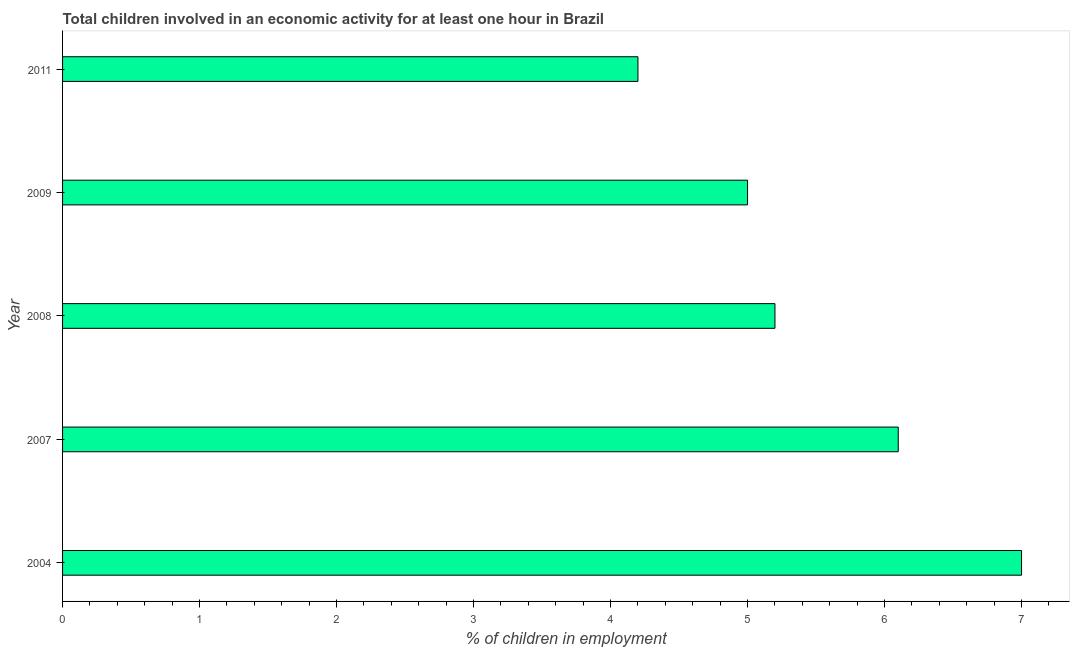Does the graph contain any zero values?
Offer a very short reply. No. Does the graph contain grids?
Provide a short and direct response. No. What is the title of the graph?
Make the answer very short. Total children involved in an economic activity for at least one hour in Brazil. What is the label or title of the X-axis?
Your answer should be compact. % of children in employment. What is the label or title of the Y-axis?
Your answer should be very brief. Year. Across all years, what is the maximum percentage of children in employment?
Make the answer very short. 7. In which year was the percentage of children in employment maximum?
Keep it short and to the point. 2004. What is the difference between the percentage of children in employment in 2009 and 2011?
Ensure brevity in your answer.  0.8. In how many years, is the percentage of children in employment greater than 0.4 %?
Provide a succinct answer. 5. What is the ratio of the percentage of children in employment in 2004 to that in 2009?
Your answer should be very brief. 1.4. Is the percentage of children in employment in 2007 less than that in 2011?
Your answer should be very brief. No. Is the difference between the percentage of children in employment in 2007 and 2008 greater than the difference between any two years?
Keep it short and to the point. No. What is the difference between the highest and the lowest percentage of children in employment?
Give a very brief answer. 2.8. How many bars are there?
Offer a terse response. 5. Are all the bars in the graph horizontal?
Make the answer very short. Yes. How many years are there in the graph?
Give a very brief answer. 5. What is the % of children in employment of 2007?
Your answer should be very brief. 6.1. What is the % of children in employment in 2008?
Make the answer very short. 5.2. What is the % of children in employment in 2009?
Offer a terse response. 5. What is the difference between the % of children in employment in 2004 and 2007?
Your answer should be very brief. 0.9. What is the difference between the % of children in employment in 2004 and 2009?
Provide a succinct answer. 2. What is the difference between the % of children in employment in 2007 and 2008?
Give a very brief answer. 0.9. What is the difference between the % of children in employment in 2007 and 2009?
Provide a succinct answer. 1.1. What is the difference between the % of children in employment in 2007 and 2011?
Provide a short and direct response. 1.9. What is the difference between the % of children in employment in 2009 and 2011?
Give a very brief answer. 0.8. What is the ratio of the % of children in employment in 2004 to that in 2007?
Your answer should be compact. 1.15. What is the ratio of the % of children in employment in 2004 to that in 2008?
Your answer should be compact. 1.35. What is the ratio of the % of children in employment in 2004 to that in 2009?
Provide a short and direct response. 1.4. What is the ratio of the % of children in employment in 2004 to that in 2011?
Offer a very short reply. 1.67. What is the ratio of the % of children in employment in 2007 to that in 2008?
Your answer should be very brief. 1.17. What is the ratio of the % of children in employment in 2007 to that in 2009?
Your answer should be compact. 1.22. What is the ratio of the % of children in employment in 2007 to that in 2011?
Your answer should be compact. 1.45. What is the ratio of the % of children in employment in 2008 to that in 2011?
Provide a short and direct response. 1.24. What is the ratio of the % of children in employment in 2009 to that in 2011?
Offer a very short reply. 1.19. 